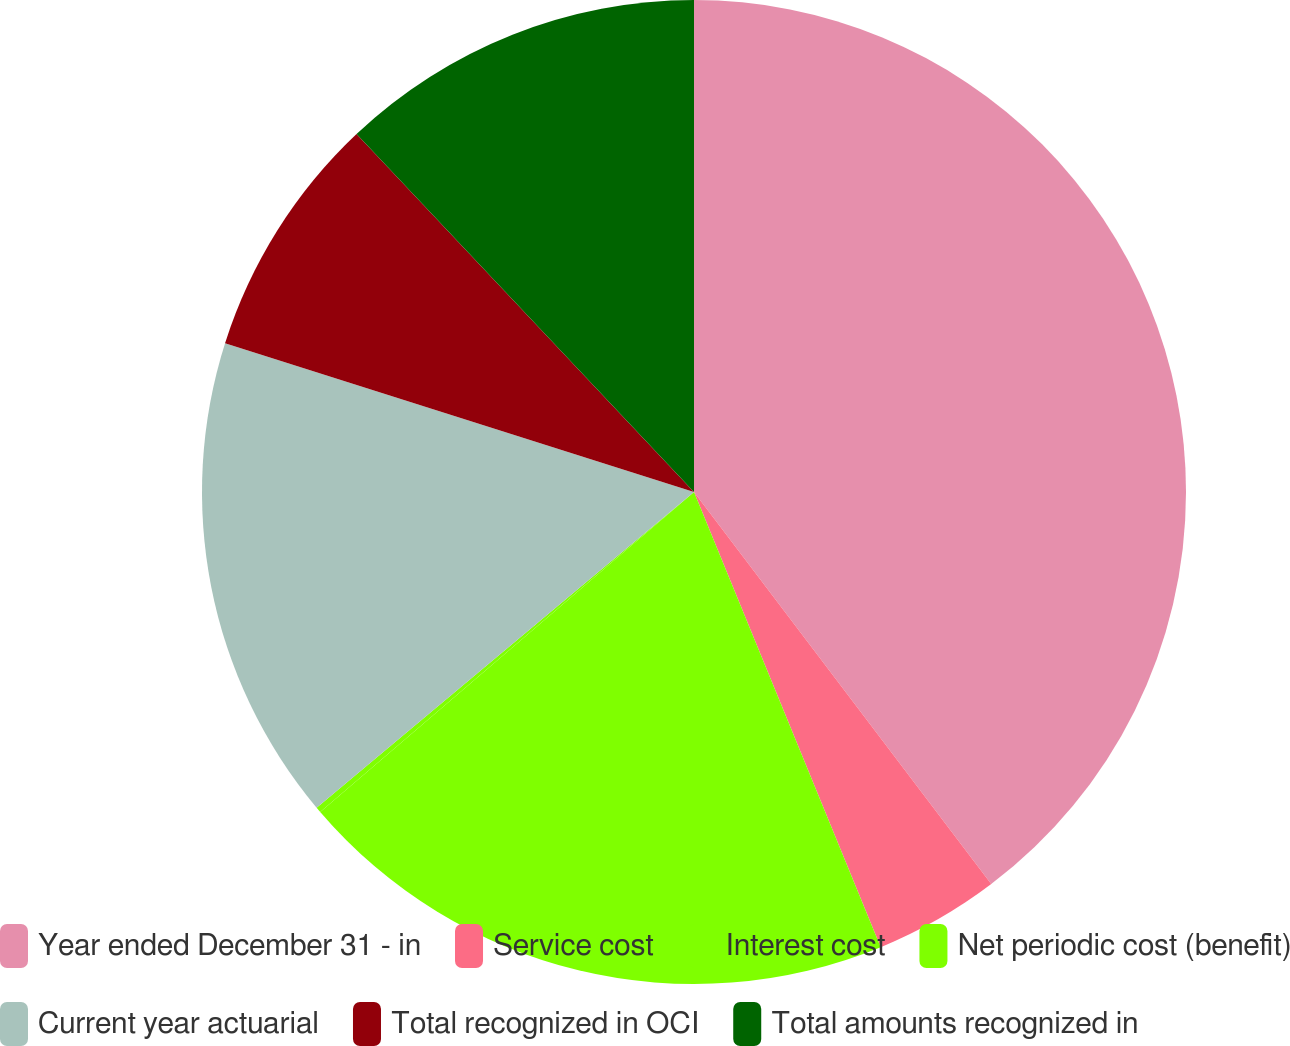Convert chart to OTSL. <chart><loc_0><loc_0><loc_500><loc_500><pie_chart><fcel>Year ended December 31 - in<fcel>Service cost<fcel>Interest cost<fcel>Net periodic cost (benefit)<fcel>Current year actuarial<fcel>Total recognized in OCI<fcel>Total amounts recognized in<nl><fcel>39.68%<fcel>4.13%<fcel>19.93%<fcel>0.18%<fcel>15.98%<fcel>8.08%<fcel>12.03%<nl></chart> 